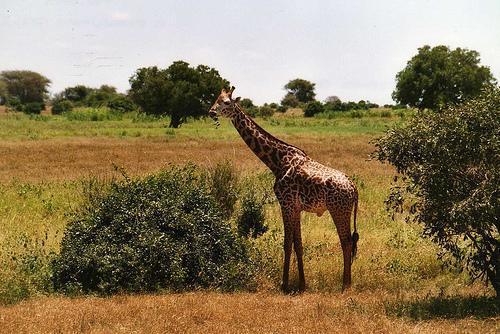How many giraffes are there?
Give a very brief answer. 1. 